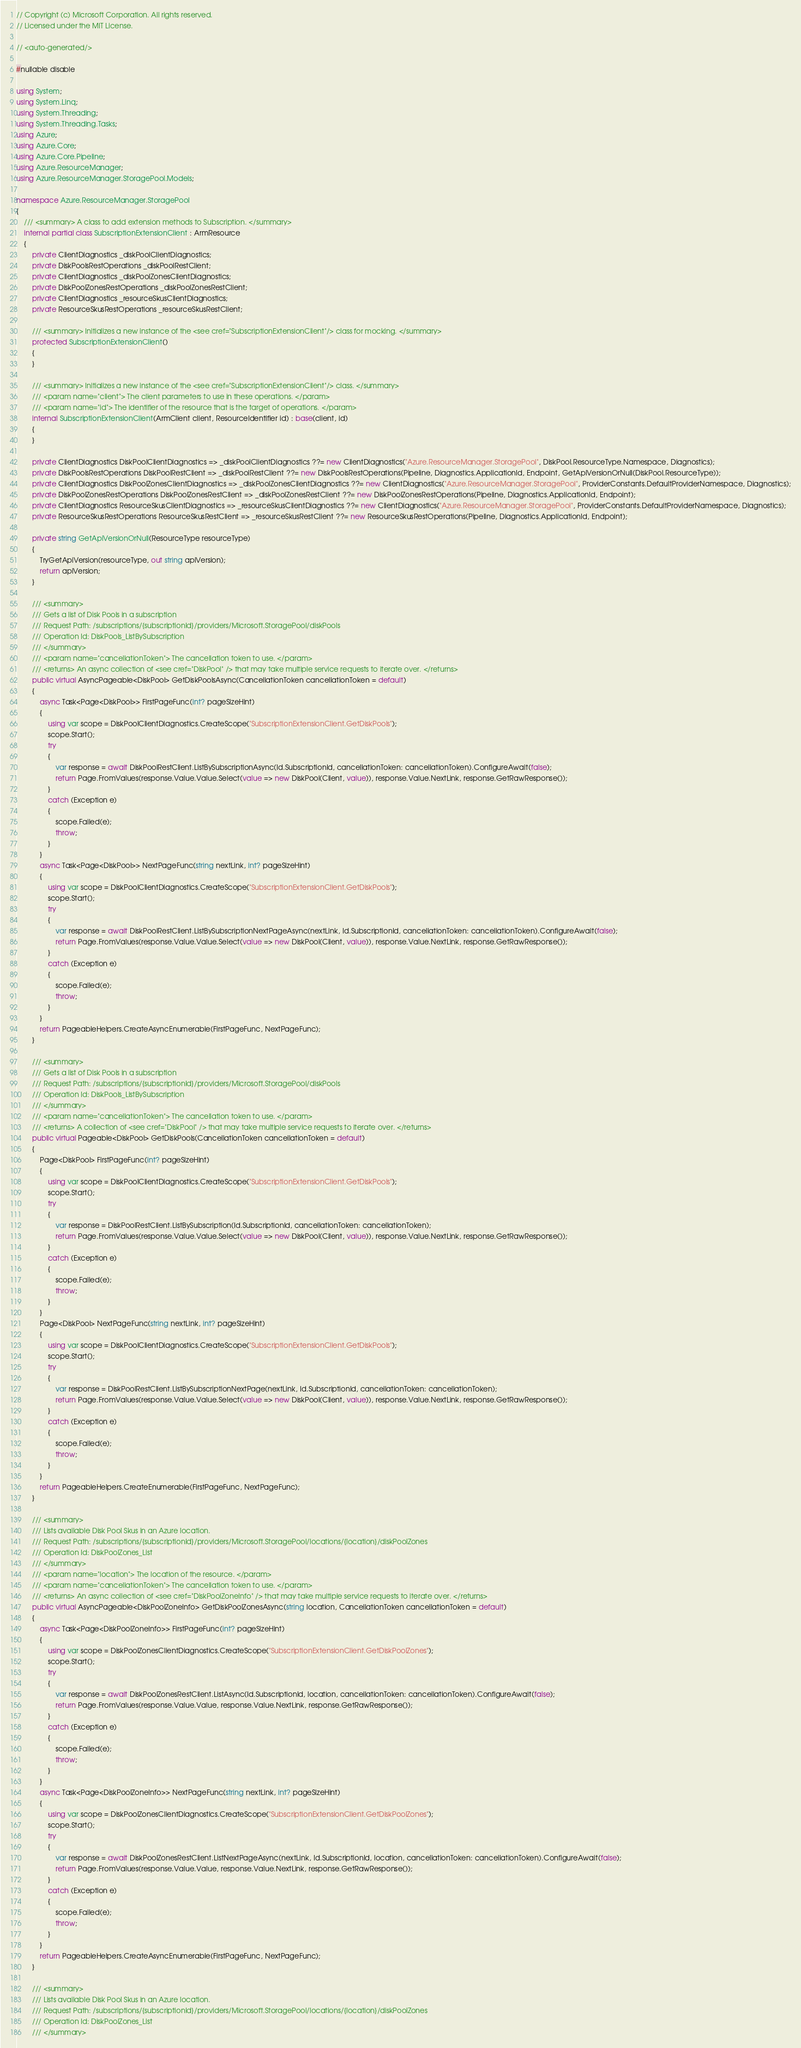<code> <loc_0><loc_0><loc_500><loc_500><_C#_>// Copyright (c) Microsoft Corporation. All rights reserved.
// Licensed under the MIT License.

// <auto-generated/>

#nullable disable

using System;
using System.Linq;
using System.Threading;
using System.Threading.Tasks;
using Azure;
using Azure.Core;
using Azure.Core.Pipeline;
using Azure.ResourceManager;
using Azure.ResourceManager.StoragePool.Models;

namespace Azure.ResourceManager.StoragePool
{
    /// <summary> A class to add extension methods to Subscription. </summary>
    internal partial class SubscriptionExtensionClient : ArmResource
    {
        private ClientDiagnostics _diskPoolClientDiagnostics;
        private DiskPoolsRestOperations _diskPoolRestClient;
        private ClientDiagnostics _diskPoolZonesClientDiagnostics;
        private DiskPoolZonesRestOperations _diskPoolZonesRestClient;
        private ClientDiagnostics _resourceSkusClientDiagnostics;
        private ResourceSkusRestOperations _resourceSkusRestClient;

        /// <summary> Initializes a new instance of the <see cref="SubscriptionExtensionClient"/> class for mocking. </summary>
        protected SubscriptionExtensionClient()
        {
        }

        /// <summary> Initializes a new instance of the <see cref="SubscriptionExtensionClient"/> class. </summary>
        /// <param name="client"> The client parameters to use in these operations. </param>
        /// <param name="id"> The identifier of the resource that is the target of operations. </param>
        internal SubscriptionExtensionClient(ArmClient client, ResourceIdentifier id) : base(client, id)
        {
        }

        private ClientDiagnostics DiskPoolClientDiagnostics => _diskPoolClientDiagnostics ??= new ClientDiagnostics("Azure.ResourceManager.StoragePool", DiskPool.ResourceType.Namespace, Diagnostics);
        private DiskPoolsRestOperations DiskPoolRestClient => _diskPoolRestClient ??= new DiskPoolsRestOperations(Pipeline, Diagnostics.ApplicationId, Endpoint, GetApiVersionOrNull(DiskPool.ResourceType));
        private ClientDiagnostics DiskPoolZonesClientDiagnostics => _diskPoolZonesClientDiagnostics ??= new ClientDiagnostics("Azure.ResourceManager.StoragePool", ProviderConstants.DefaultProviderNamespace, Diagnostics);
        private DiskPoolZonesRestOperations DiskPoolZonesRestClient => _diskPoolZonesRestClient ??= new DiskPoolZonesRestOperations(Pipeline, Diagnostics.ApplicationId, Endpoint);
        private ClientDiagnostics ResourceSkusClientDiagnostics => _resourceSkusClientDiagnostics ??= new ClientDiagnostics("Azure.ResourceManager.StoragePool", ProviderConstants.DefaultProviderNamespace, Diagnostics);
        private ResourceSkusRestOperations ResourceSkusRestClient => _resourceSkusRestClient ??= new ResourceSkusRestOperations(Pipeline, Diagnostics.ApplicationId, Endpoint);

        private string GetApiVersionOrNull(ResourceType resourceType)
        {
            TryGetApiVersion(resourceType, out string apiVersion);
            return apiVersion;
        }

        /// <summary>
        /// Gets a list of Disk Pools in a subscription
        /// Request Path: /subscriptions/{subscriptionId}/providers/Microsoft.StoragePool/diskPools
        /// Operation Id: DiskPools_ListBySubscription
        /// </summary>
        /// <param name="cancellationToken"> The cancellation token to use. </param>
        /// <returns> An async collection of <see cref="DiskPool" /> that may take multiple service requests to iterate over. </returns>
        public virtual AsyncPageable<DiskPool> GetDiskPoolsAsync(CancellationToken cancellationToken = default)
        {
            async Task<Page<DiskPool>> FirstPageFunc(int? pageSizeHint)
            {
                using var scope = DiskPoolClientDiagnostics.CreateScope("SubscriptionExtensionClient.GetDiskPools");
                scope.Start();
                try
                {
                    var response = await DiskPoolRestClient.ListBySubscriptionAsync(Id.SubscriptionId, cancellationToken: cancellationToken).ConfigureAwait(false);
                    return Page.FromValues(response.Value.Value.Select(value => new DiskPool(Client, value)), response.Value.NextLink, response.GetRawResponse());
                }
                catch (Exception e)
                {
                    scope.Failed(e);
                    throw;
                }
            }
            async Task<Page<DiskPool>> NextPageFunc(string nextLink, int? pageSizeHint)
            {
                using var scope = DiskPoolClientDiagnostics.CreateScope("SubscriptionExtensionClient.GetDiskPools");
                scope.Start();
                try
                {
                    var response = await DiskPoolRestClient.ListBySubscriptionNextPageAsync(nextLink, Id.SubscriptionId, cancellationToken: cancellationToken).ConfigureAwait(false);
                    return Page.FromValues(response.Value.Value.Select(value => new DiskPool(Client, value)), response.Value.NextLink, response.GetRawResponse());
                }
                catch (Exception e)
                {
                    scope.Failed(e);
                    throw;
                }
            }
            return PageableHelpers.CreateAsyncEnumerable(FirstPageFunc, NextPageFunc);
        }

        /// <summary>
        /// Gets a list of Disk Pools in a subscription
        /// Request Path: /subscriptions/{subscriptionId}/providers/Microsoft.StoragePool/diskPools
        /// Operation Id: DiskPools_ListBySubscription
        /// </summary>
        /// <param name="cancellationToken"> The cancellation token to use. </param>
        /// <returns> A collection of <see cref="DiskPool" /> that may take multiple service requests to iterate over. </returns>
        public virtual Pageable<DiskPool> GetDiskPools(CancellationToken cancellationToken = default)
        {
            Page<DiskPool> FirstPageFunc(int? pageSizeHint)
            {
                using var scope = DiskPoolClientDiagnostics.CreateScope("SubscriptionExtensionClient.GetDiskPools");
                scope.Start();
                try
                {
                    var response = DiskPoolRestClient.ListBySubscription(Id.SubscriptionId, cancellationToken: cancellationToken);
                    return Page.FromValues(response.Value.Value.Select(value => new DiskPool(Client, value)), response.Value.NextLink, response.GetRawResponse());
                }
                catch (Exception e)
                {
                    scope.Failed(e);
                    throw;
                }
            }
            Page<DiskPool> NextPageFunc(string nextLink, int? pageSizeHint)
            {
                using var scope = DiskPoolClientDiagnostics.CreateScope("SubscriptionExtensionClient.GetDiskPools");
                scope.Start();
                try
                {
                    var response = DiskPoolRestClient.ListBySubscriptionNextPage(nextLink, Id.SubscriptionId, cancellationToken: cancellationToken);
                    return Page.FromValues(response.Value.Value.Select(value => new DiskPool(Client, value)), response.Value.NextLink, response.GetRawResponse());
                }
                catch (Exception e)
                {
                    scope.Failed(e);
                    throw;
                }
            }
            return PageableHelpers.CreateEnumerable(FirstPageFunc, NextPageFunc);
        }

        /// <summary>
        /// Lists available Disk Pool Skus in an Azure location.
        /// Request Path: /subscriptions/{subscriptionId}/providers/Microsoft.StoragePool/locations/{location}/diskPoolZones
        /// Operation Id: DiskPoolZones_List
        /// </summary>
        /// <param name="location"> The location of the resource. </param>
        /// <param name="cancellationToken"> The cancellation token to use. </param>
        /// <returns> An async collection of <see cref="DiskPoolZoneInfo" /> that may take multiple service requests to iterate over. </returns>
        public virtual AsyncPageable<DiskPoolZoneInfo> GetDiskPoolZonesAsync(string location, CancellationToken cancellationToken = default)
        {
            async Task<Page<DiskPoolZoneInfo>> FirstPageFunc(int? pageSizeHint)
            {
                using var scope = DiskPoolZonesClientDiagnostics.CreateScope("SubscriptionExtensionClient.GetDiskPoolZones");
                scope.Start();
                try
                {
                    var response = await DiskPoolZonesRestClient.ListAsync(Id.SubscriptionId, location, cancellationToken: cancellationToken).ConfigureAwait(false);
                    return Page.FromValues(response.Value.Value, response.Value.NextLink, response.GetRawResponse());
                }
                catch (Exception e)
                {
                    scope.Failed(e);
                    throw;
                }
            }
            async Task<Page<DiskPoolZoneInfo>> NextPageFunc(string nextLink, int? pageSizeHint)
            {
                using var scope = DiskPoolZonesClientDiagnostics.CreateScope("SubscriptionExtensionClient.GetDiskPoolZones");
                scope.Start();
                try
                {
                    var response = await DiskPoolZonesRestClient.ListNextPageAsync(nextLink, Id.SubscriptionId, location, cancellationToken: cancellationToken).ConfigureAwait(false);
                    return Page.FromValues(response.Value.Value, response.Value.NextLink, response.GetRawResponse());
                }
                catch (Exception e)
                {
                    scope.Failed(e);
                    throw;
                }
            }
            return PageableHelpers.CreateAsyncEnumerable(FirstPageFunc, NextPageFunc);
        }

        /// <summary>
        /// Lists available Disk Pool Skus in an Azure location.
        /// Request Path: /subscriptions/{subscriptionId}/providers/Microsoft.StoragePool/locations/{location}/diskPoolZones
        /// Operation Id: DiskPoolZones_List
        /// </summary></code> 